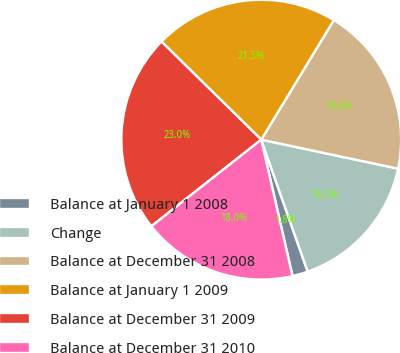Convert chart to OTSL. <chart><loc_0><loc_0><loc_500><loc_500><pie_chart><fcel>Balance at January 1 2008<fcel>Change<fcel>Balance at December 31 2008<fcel>Balance at January 1 2009<fcel>Balance at December 31 2009<fcel>Balance at December 31 2010<nl><fcel>1.8%<fcel>16.29%<fcel>19.64%<fcel>21.32%<fcel>22.99%<fcel>17.96%<nl></chart> 